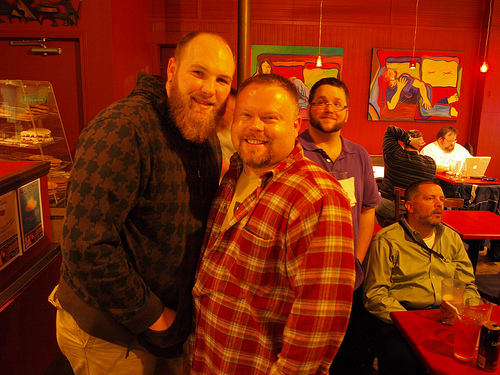<image>
Is the painting next to the man? No. The painting is not positioned next to the man. They are located in different areas of the scene. Where is the computer in relation to the man? Is it next to the man? No. The computer is not positioned next to the man. They are located in different areas of the scene. Is there a light fixture in front of the painting? Yes. The light fixture is positioned in front of the painting, appearing closer to the camera viewpoint. 